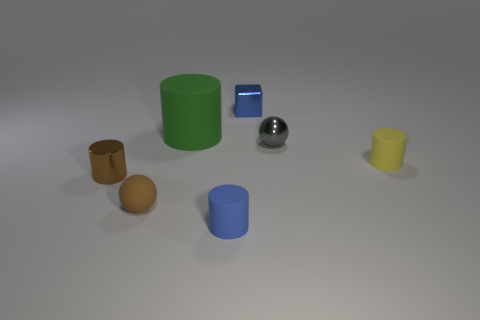There is a small matte object that is the same color as the small shiny cylinder; what is its shape?
Keep it short and to the point. Sphere. There is a sphere that is behind the brown rubber sphere; what number of large green matte things are in front of it?
Ensure brevity in your answer.  0. Are there any other green objects of the same shape as the green object?
Your answer should be very brief. No. There is a sphere behind the yellow matte object; does it have the same size as the cylinder right of the gray shiny thing?
Give a very brief answer. Yes. What is the shape of the tiny metal object in front of the rubber cylinder that is on the right side of the blue block?
Provide a short and direct response. Cylinder. How many blue matte cylinders have the same size as the brown metal cylinder?
Make the answer very short. 1. Are there any big blue cylinders?
Your response must be concise. No. Is there any other thing that has the same color as the large object?
Offer a very short reply. No. What is the shape of the tiny brown thing that is made of the same material as the small blue block?
Make the answer very short. Cylinder. There is a matte cylinder right of the cylinder that is in front of the small shiny object on the left side of the small blue matte thing; what is its color?
Your response must be concise. Yellow. 